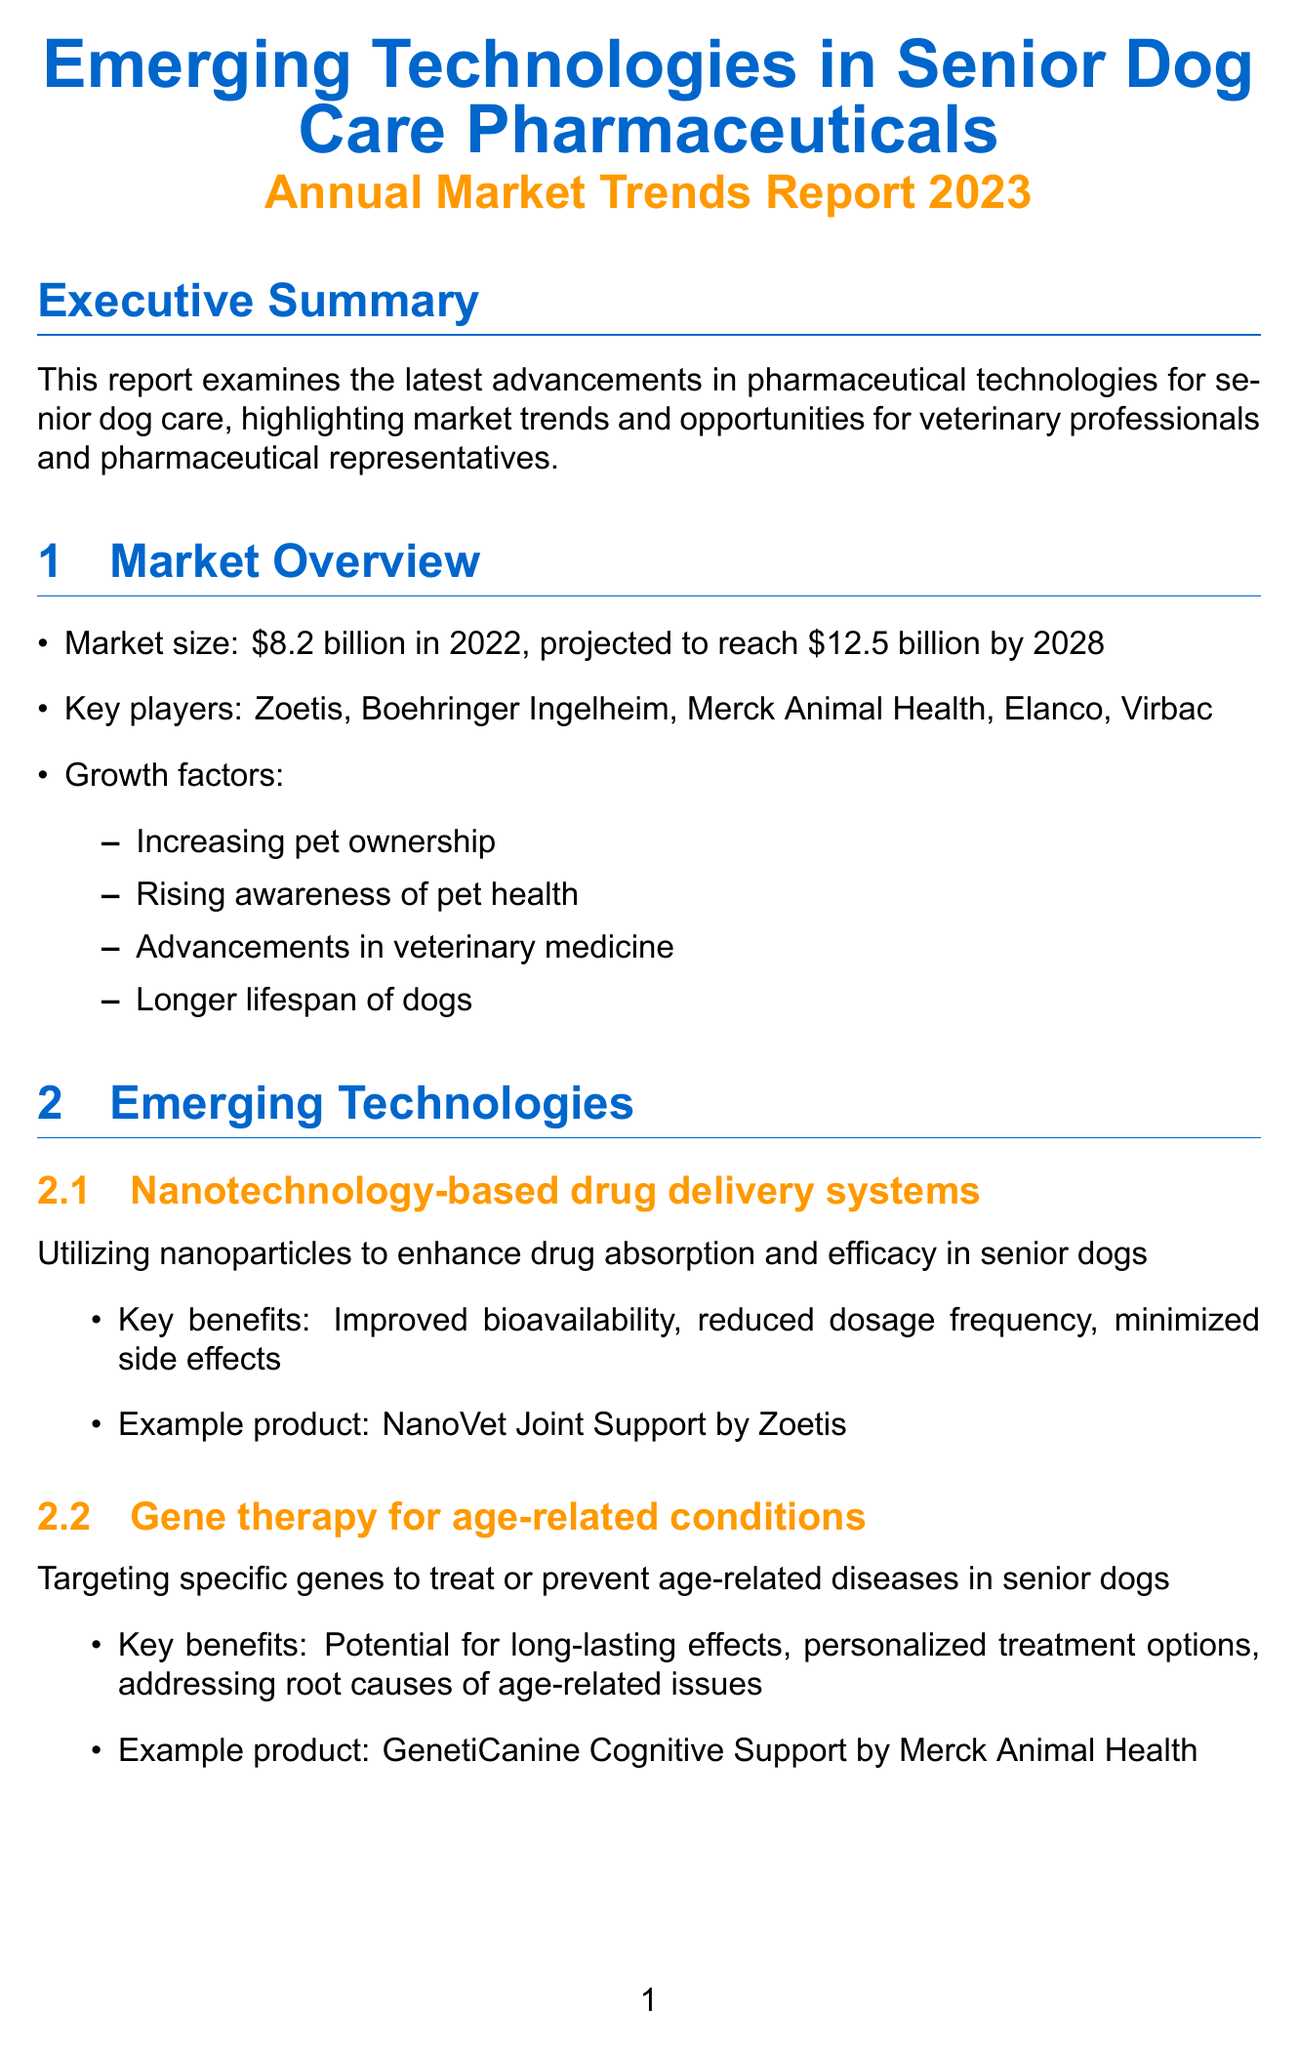what is the projected market size for senior dog care pharmaceuticals by 2028? The projected market size is indicated in the report as expected to reach $12.5 billion by 2028.
Answer: $12.5 billion who is the key player mentioned in the emerging technologies section? The report highlights several key players, including Zoetis, which is listed in the section on emerging technologies.
Answer: Zoetis what technology is used to enhance drug absorption in senior dogs? The document describes nanotechnology-based drug delivery systems as the technology used for enhancing drug absorption.
Answer: Nanotechnology-based drug delivery systems which market trend focuses on products for cognitive decline in senior dogs? The report specifies the trend of growing emphasis on products aimed at cognitive health, directly addressing cognitive decline in senior dogs.
Answer: Focus on cognitive health what is one example of a product utilizing 3D printing in senior dog care? The report provides an example product in the 3D-printed medications section, which is PrintRx Senior Multivitamin.
Answer: PrintRx Senior Multivitamin what is a challenge related to new technologies mentioned in the report? The document discusses several challenges, including regulatory hurdles as one significant challenge faced in adopting new technologies.
Answer: Regulatory hurdles what opportunity is associated with pet owner education on new technologies? The report mentions the development of comprehensive educational materials and programs as an opportunity linked with educating pet owners about new technologies.
Answer: Development of comprehensive educational materials how much was the market size for senior dog care pharmaceuticals in 2022? The document clearly states that the market size was $8.2 billion in 2022.
Answer: $8.2 billion 